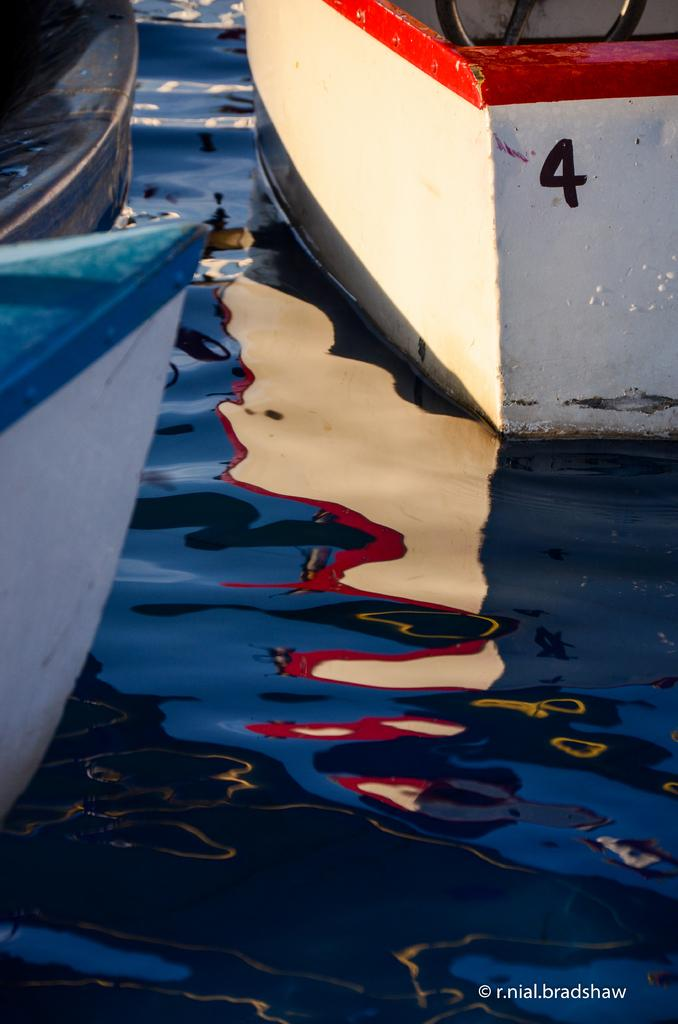What can be seen in the image? There are boats in the image. Where are the boats located? The boats are in a water body. What type of note is being played by the boats in the image? There is no indication in the image that the boats are playing a note, as boats do not have the ability to produce sound in that manner. 